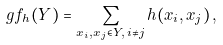<formula> <loc_0><loc_0><loc_500><loc_500>\ g f _ { h } ( Y ) = \sum _ { x _ { i } , x _ { j } \in Y , \, i \neq j } h ( x _ { i } , x _ { j } ) \, ,</formula> 